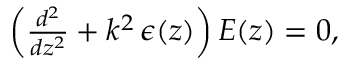Convert formula to latex. <formula><loc_0><loc_0><loc_500><loc_500>\begin{array} { r } { \left ( \frac { d ^ { 2 } } { d z ^ { 2 } } + k ^ { 2 } \, \epsilon ( z ) \right ) E ( z ) = 0 , } \end{array}</formula> 